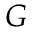Convert formula to latex. <formula><loc_0><loc_0><loc_500><loc_500>G</formula> 